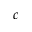Convert formula to latex. <formula><loc_0><loc_0><loc_500><loc_500>c</formula> 